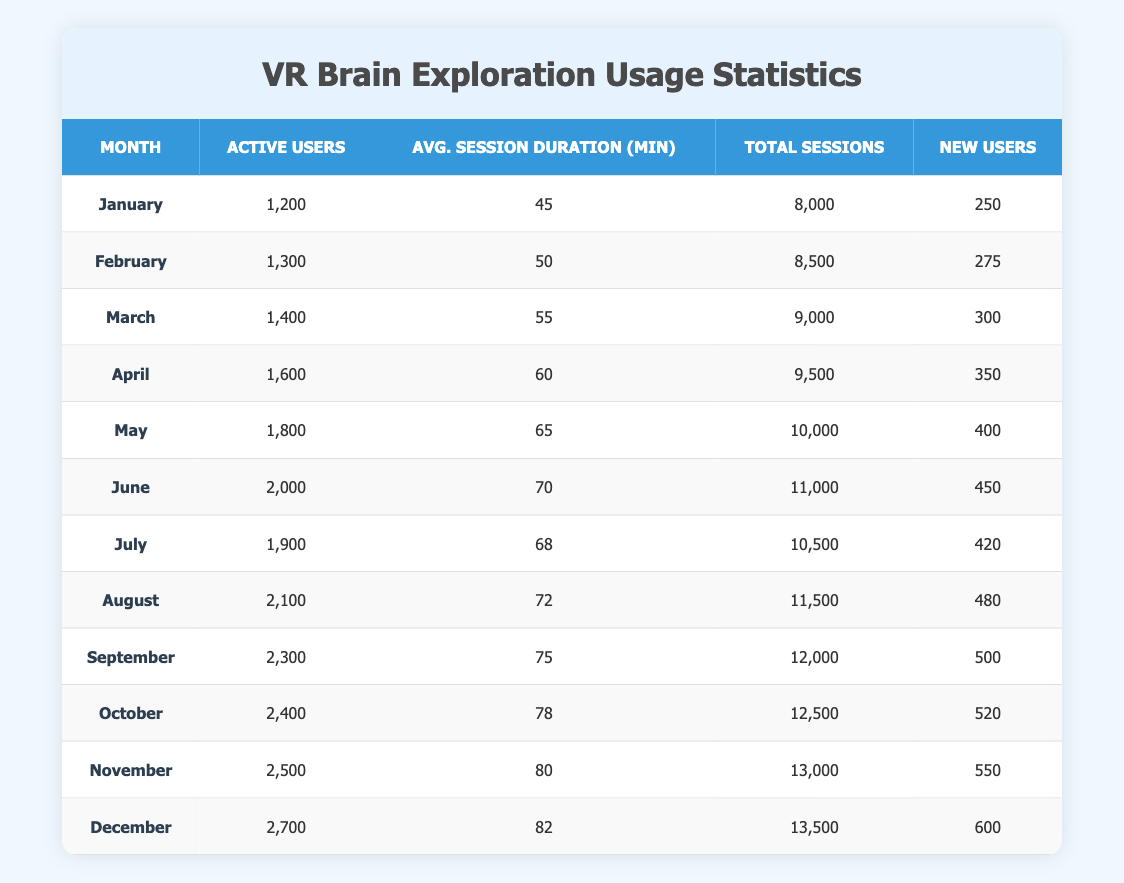What was the total number of active users in December? In December, the data shows that there were 2,700 active users. This is listed directly in the table under the "Active Users" column for the month of December.
Answer: 2,700 Which month had the highest average session duration and what was the duration? The month with the highest average session duration is December, with an average duration of 82 minutes. This value can be found in the "Avg. Session Duration (min)" column for December.
Answer: 82 What is the increase in active users from January to June? The number of active users in January was 1,200, and in June, it was 2,000. To calculate the increase, we subtract January's active users from June's: 2,000 - 1,200 = 800.
Answer: 800 Did the number of new users surpass 500 in any month? In the table, we can see that the number of new users exceeded 500 only in December, when it reached 600. This is determined by inspecting the "New Users" column across all months.
Answer: Yes What is the monthly average of total sessions from January to December? To calculate the monthly average, sum the total sessions from each month: 8,000 + 8,500 + 9,000 + 9,500 + 10,000 + 11,000 + 10,500 + 11,500 + 12,000 + 12,500 + 13,000 + 13,500 = 136,000. There are 12 months, so the average is 136,000 / 12 = 11,333.33 (rounded down to 11,333 when reporting).
Answer: 11,333 How many months showed an increase in active users from the previous month? By reviewing the table, we can see that every month from February to December showed an increase in active users compared to the previous month. By counting these instances, we find that there are 11 months with increases.
Answer: 11 